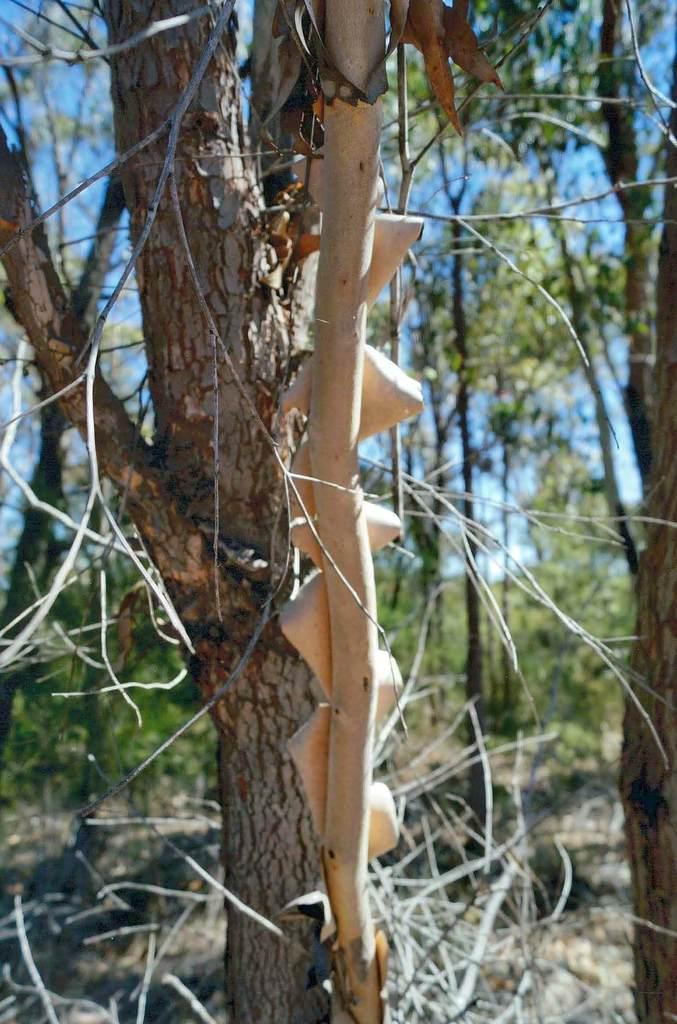Can you describe this image briefly? In this image I can see few trees which are brown and cream in color. In the background I can see few trees and the sky. 